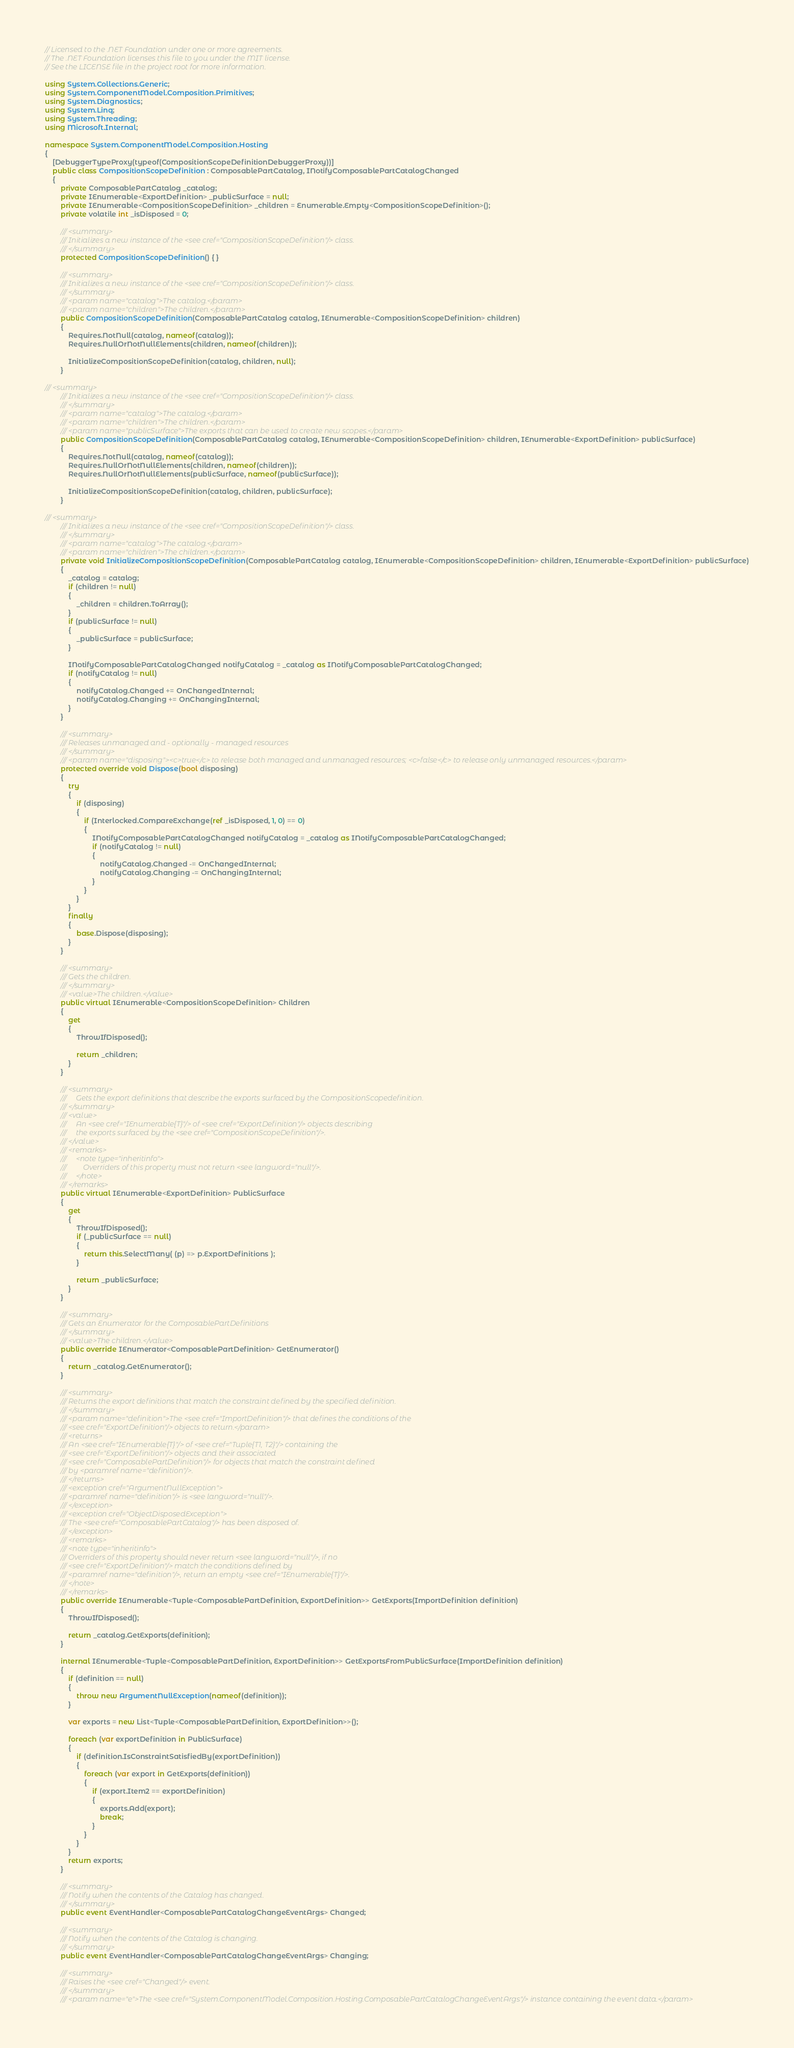<code> <loc_0><loc_0><loc_500><loc_500><_C#_>// Licensed to the .NET Foundation under one or more agreements.
// The .NET Foundation licenses this file to you under the MIT license.
// See the LICENSE file in the project root for more information.

using System.Collections.Generic;
using System.ComponentModel.Composition.Primitives;
using System.Diagnostics;
using System.Linq;
using System.Threading;
using Microsoft.Internal;

namespace System.ComponentModel.Composition.Hosting
{
    [DebuggerTypeProxy(typeof(CompositionScopeDefinitionDebuggerProxy))]
    public class CompositionScopeDefinition : ComposablePartCatalog, INotifyComposablePartCatalogChanged
    {
        private ComposablePartCatalog _catalog;
        private IEnumerable<ExportDefinition> _publicSurface = null;
        private IEnumerable<CompositionScopeDefinition> _children = Enumerable.Empty<CompositionScopeDefinition>();
        private volatile int _isDisposed = 0;

        /// <summary>
        /// Initializes a new instance of the <see cref="CompositionScopeDefinition"/> class.
        /// </summary>
        protected CompositionScopeDefinition() { }

        /// <summary>
        /// Initializes a new instance of the <see cref="CompositionScopeDefinition"/> class.
        /// </summary>
        /// <param name="catalog">The catalog.</param>
        /// <param name="children">The children.</param>
        public CompositionScopeDefinition(ComposablePartCatalog catalog, IEnumerable<CompositionScopeDefinition> children)
        {
            Requires.NotNull(catalog, nameof(catalog));
            Requires.NullOrNotNullElements(children, nameof(children));

            InitializeCompositionScopeDefinition(catalog, children, null);
        }

/// <summary>
        /// Initializes a new instance of the <see cref="CompositionScopeDefinition"/> class.
        /// </summary>
        /// <param name="catalog">The catalog.</param>
        /// <param name="children">The children.</param>
        /// <param name="publicSurface">The exports that can be used to create new scopes.</param>
        public CompositionScopeDefinition(ComposablePartCatalog catalog, IEnumerable<CompositionScopeDefinition> children, IEnumerable<ExportDefinition> publicSurface)
        {
            Requires.NotNull(catalog, nameof(catalog));
            Requires.NullOrNotNullElements(children, nameof(children));
            Requires.NullOrNotNullElements(publicSurface, nameof(publicSurface));

            InitializeCompositionScopeDefinition(catalog, children, publicSurface);
        }

/// <summary>
        /// Initializes a new instance of the <see cref="CompositionScopeDefinition"/> class.
        /// </summary>
        /// <param name="catalog">The catalog.</param>
        /// <param name="children">The children.</param>
        private void InitializeCompositionScopeDefinition(ComposablePartCatalog catalog, IEnumerable<CompositionScopeDefinition> children, IEnumerable<ExportDefinition> publicSurface)
        {
            _catalog = catalog;
            if (children != null)
            {
                _children = children.ToArray();
            }
            if (publicSurface != null)
            {
                _publicSurface = publicSurface;
            }

            INotifyComposablePartCatalogChanged notifyCatalog = _catalog as INotifyComposablePartCatalogChanged;
            if (notifyCatalog != null)
            {
                notifyCatalog.Changed += OnChangedInternal;
                notifyCatalog.Changing += OnChangingInternal;
            }
        }

        /// <summary>
        /// Releases unmanaged and - optionally - managed resources
        /// </summary>
        /// <param name="disposing"><c>true</c> to release both managed and unmanaged resources; <c>false</c> to release only unmanaged resources.</param>
        protected override void Dispose(bool disposing)
        {
            try
            {
                if (disposing)
                {
                    if (Interlocked.CompareExchange(ref _isDisposed, 1, 0) == 0)
                    {
                        INotifyComposablePartCatalogChanged notifyCatalog = _catalog as INotifyComposablePartCatalogChanged;
                        if (notifyCatalog != null)
                        {
                            notifyCatalog.Changed -= OnChangedInternal;
                            notifyCatalog.Changing -= OnChangingInternal;
                        }
                    }
                }
            }
            finally
            {
                base.Dispose(disposing);
            }
        }

        /// <summary>
        /// Gets the children.
        /// </summary>
        /// <value>The children.</value>
        public virtual IEnumerable<CompositionScopeDefinition> Children
        {
            get
            {
                ThrowIfDisposed();

                return _children;
            }
        }

        /// <summary>
        ///     Gets the export definitions that describe the exports surfaced by the CompositionScopedefinition.
        /// </summary>
        /// <value>
        ///     An <see cref="IEnumerable{T}"/> of <see cref="ExportDefinition"/> objects describing
        ///     the exports surfaced by the <see cref="CompositionScopeDefinition"/>.
        /// </value>
        /// <remarks>
        ///     <note type="inheritinfo">
        ///         Overriders of this property must not return <see langword="null"/>.
        ///     </note>
        /// </remarks>
        public virtual IEnumerable<ExportDefinition> PublicSurface
        {
            get
            {
                ThrowIfDisposed();
                if (_publicSurface == null)
                {
                    return this.SelectMany( (p) => p.ExportDefinitions );
                }

                return _publicSurface;
            }
        }

        /// <summary>
        /// Gets an Enumerator for the ComposablePartDefinitions
        /// </summary>
        /// <value>The children.</value>
        public override IEnumerator<ComposablePartDefinition> GetEnumerator()
        {
            return _catalog.GetEnumerator();
        }

        /// <summary>
        /// Returns the export definitions that match the constraint defined by the specified definition.
        /// </summary>
        /// <param name="definition">The <see cref="ImportDefinition"/> that defines the conditions of the
        /// <see cref="ExportDefinition"/> objects to return.</param>
        /// <returns>
        /// An <see cref="IEnumerable{T}"/> of <see cref="Tuple{T1, T2}"/> containing the
        /// <see cref="ExportDefinition"/> objects and their associated
        /// <see cref="ComposablePartDefinition"/> for objects that match the constraint defined
        /// by <paramref name="definition"/>.
        /// </returns>
        /// <exception cref="ArgumentNullException">
        /// <paramref name="definition"/> is <see langword="null"/>.
        /// </exception>
        /// <exception cref="ObjectDisposedException">
        /// The <see cref="ComposablePartCatalog"/> has been disposed of.
        /// </exception>
        /// <remarks>
        /// <note type="inheritinfo">
        /// Overriders of this property should never return <see langword="null"/>, if no
        /// <see cref="ExportDefinition"/> match the conditions defined by
        /// <paramref name="definition"/>, return an empty <see cref="IEnumerable{T}"/>.
        /// </note>
        /// </remarks>
        public override IEnumerable<Tuple<ComposablePartDefinition, ExportDefinition>> GetExports(ImportDefinition definition)
        {
            ThrowIfDisposed();

            return _catalog.GetExports(definition);
        }

        internal IEnumerable<Tuple<ComposablePartDefinition, ExportDefinition>> GetExportsFromPublicSurface(ImportDefinition definition)
        {
            if (definition == null)
            {
                throw new ArgumentNullException(nameof(definition));
            }

            var exports = new List<Tuple<ComposablePartDefinition, ExportDefinition>>();

            foreach (var exportDefinition in PublicSurface)
            {
                if (definition.IsConstraintSatisfiedBy(exportDefinition))
                {
                    foreach (var export in GetExports(definition))
                    {
                        if (export.Item2 == exportDefinition)
                        {
                            exports.Add(export);
                            break;
                        }
                    }
                }
            }
            return exports;
        }

        /// <summary>
        /// Notify when the contents of the Catalog has changed.
        /// </summary>
        public event EventHandler<ComposablePartCatalogChangeEventArgs> Changed;

        /// <summary>
        /// Notify when the contents of the Catalog is changing.
        /// </summary>
        public event EventHandler<ComposablePartCatalogChangeEventArgs> Changing;

        /// <summary>
        /// Raises the <see cref="Changed"/> event.
        /// </summary>
        /// <param name="e">The <see cref="System.ComponentModel.Composition.Hosting.ComposablePartCatalogChangeEventArgs"/> instance containing the event data.</param></code> 